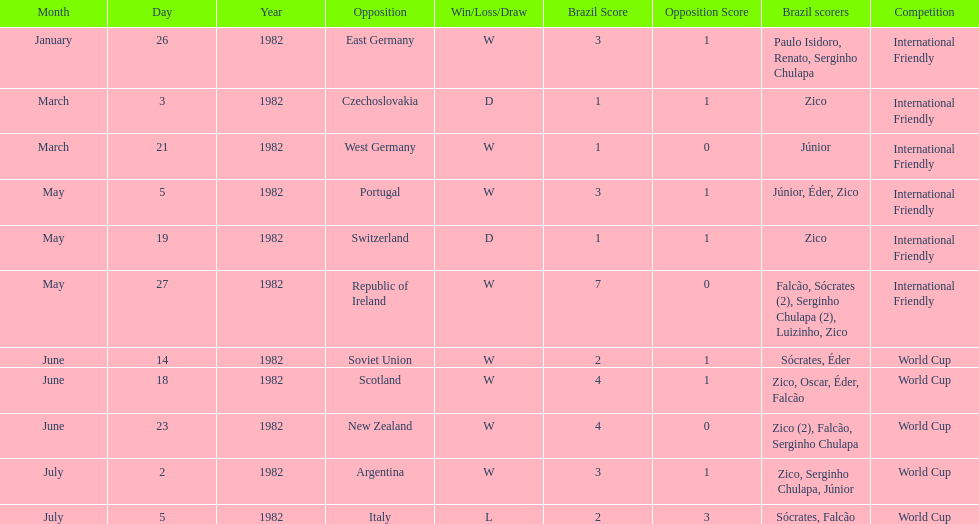What is the number of games won by brazil during the month of march 1982? 1. 